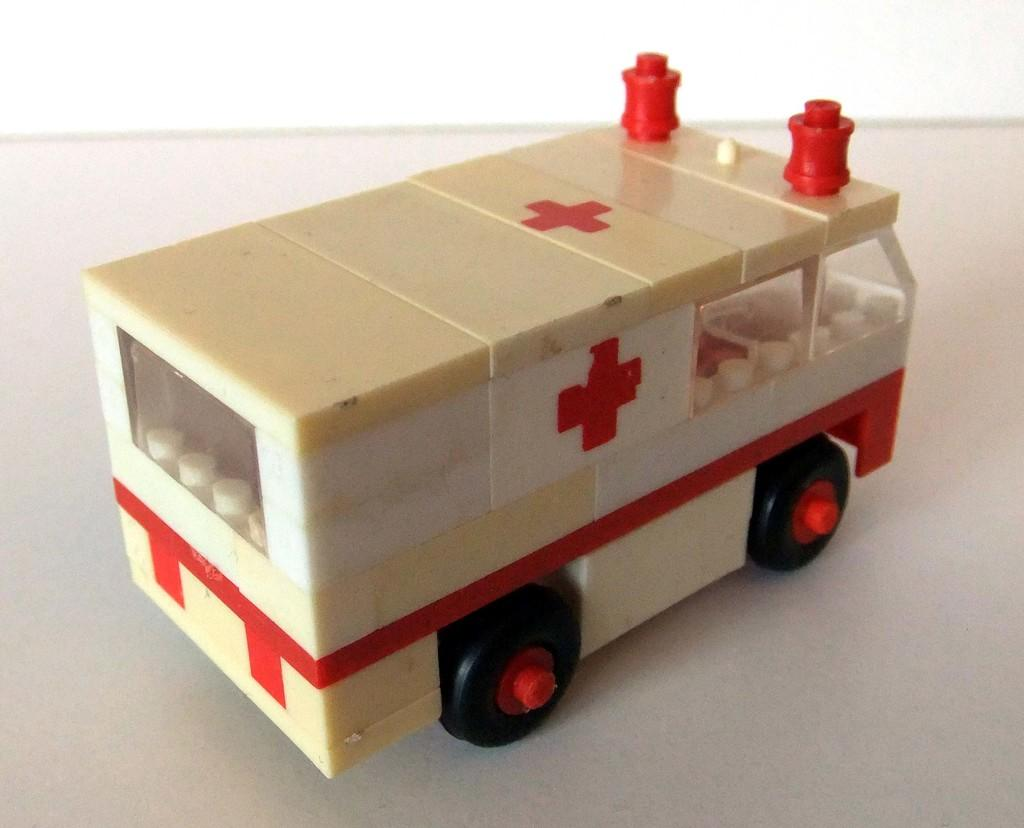What type of toy is present in the image? There is a toy ambulance in the image. What color is the surface on which the toy is placed? The toy ambulance is on a white surface. What type of quilt is being used to cover the toy ambulance in the image? There is no quilt present in the image; the toy ambulance is on a white surface. 